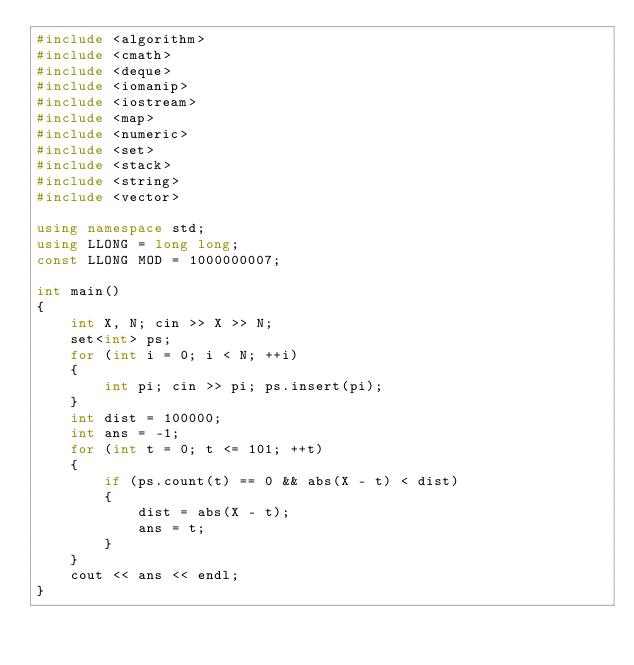Convert code to text. <code><loc_0><loc_0><loc_500><loc_500><_C++_>#include <algorithm>
#include <cmath>
#include <deque>
#include <iomanip>
#include <iostream>
#include <map>
#include <numeric>
#include <set>
#include <stack>
#include <string>
#include <vector>

using namespace std;
using LLONG = long long;
const LLONG MOD = 1000000007;

int main()
{
    int X, N; cin >> X >> N;
    set<int> ps; 
    for (int i = 0; i < N; ++i)
    {
        int pi; cin >> pi; ps.insert(pi);
    }
    int dist = 100000;
    int ans = -1;
    for (int t = 0; t <= 101; ++t)
    {
        if (ps.count(t) == 0 && abs(X - t) < dist)
        {
            dist = abs(X - t);
            ans = t;
        }
    }
    cout << ans << endl;
}
</code> 